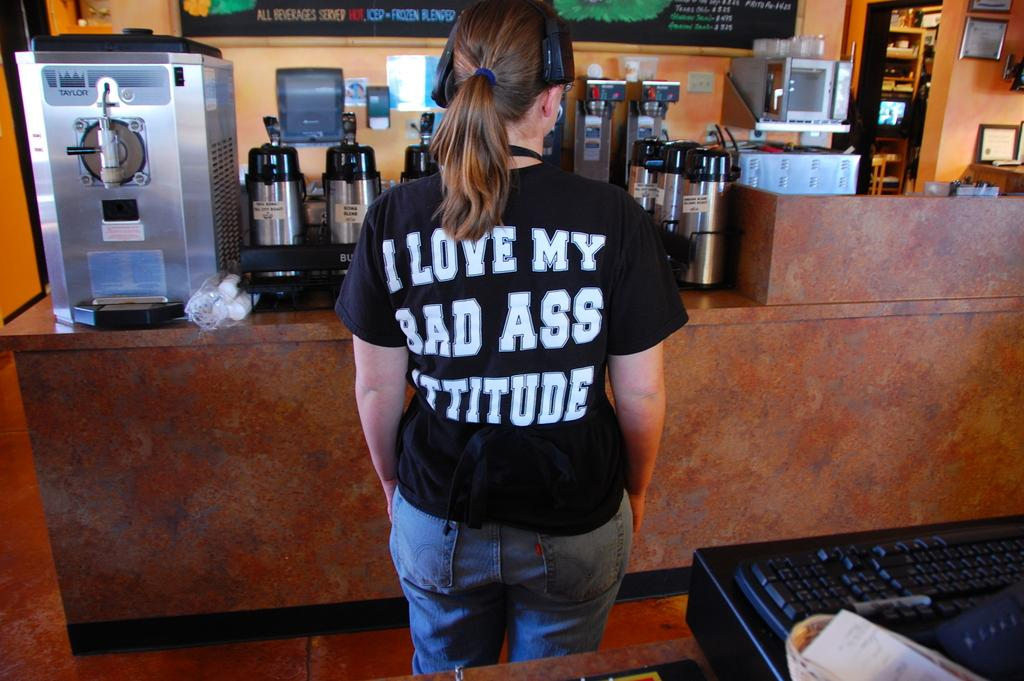<image>
Write a terse but informative summary of the picture. The person shown likes to tell the world how they love their bad ass attitude. 